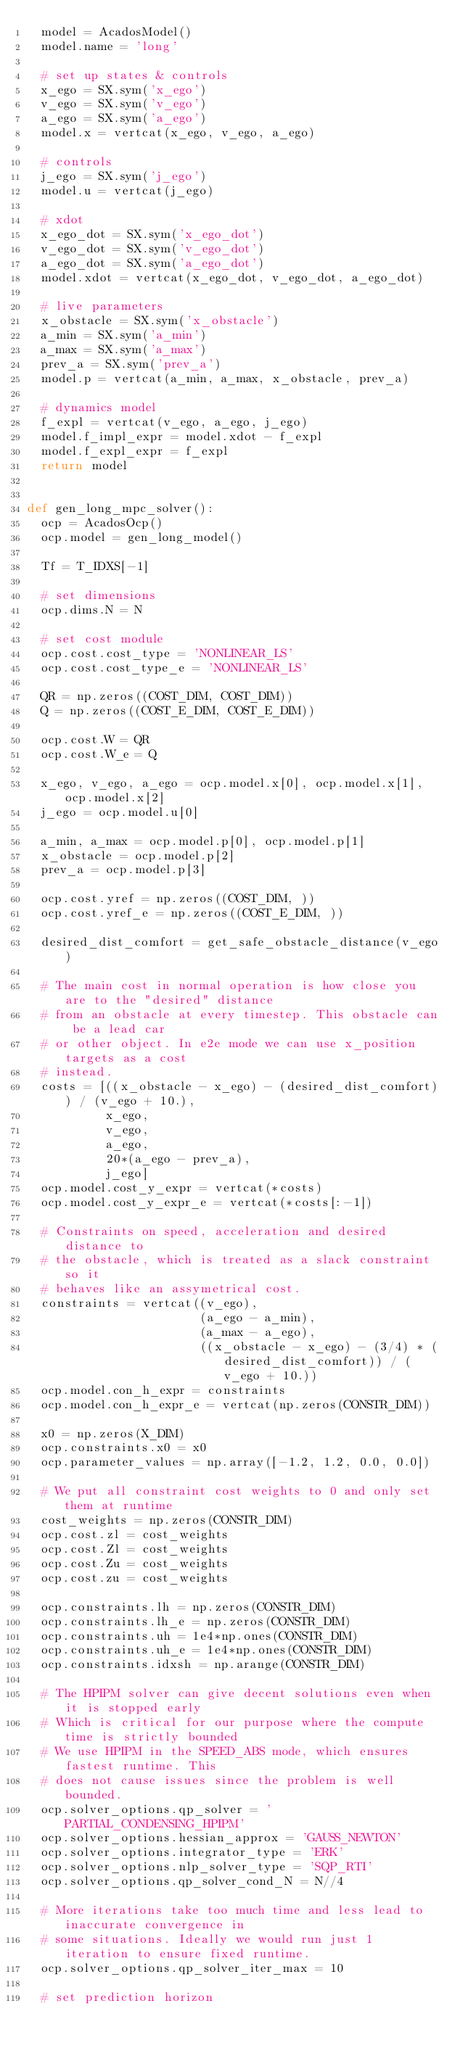<code> <loc_0><loc_0><loc_500><loc_500><_Python_>  model = AcadosModel()
  model.name = 'long'

  # set up states & controls
  x_ego = SX.sym('x_ego')
  v_ego = SX.sym('v_ego')
  a_ego = SX.sym('a_ego')
  model.x = vertcat(x_ego, v_ego, a_ego)

  # controls
  j_ego = SX.sym('j_ego')
  model.u = vertcat(j_ego)

  # xdot
  x_ego_dot = SX.sym('x_ego_dot')
  v_ego_dot = SX.sym('v_ego_dot')
  a_ego_dot = SX.sym('a_ego_dot')
  model.xdot = vertcat(x_ego_dot, v_ego_dot, a_ego_dot)

  # live parameters
  x_obstacle = SX.sym('x_obstacle')
  a_min = SX.sym('a_min')
  a_max = SX.sym('a_max')
  prev_a = SX.sym('prev_a')
  model.p = vertcat(a_min, a_max, x_obstacle, prev_a)

  # dynamics model
  f_expl = vertcat(v_ego, a_ego, j_ego)
  model.f_impl_expr = model.xdot - f_expl
  model.f_expl_expr = f_expl
  return model


def gen_long_mpc_solver():
  ocp = AcadosOcp()
  ocp.model = gen_long_model()

  Tf = T_IDXS[-1]

  # set dimensions
  ocp.dims.N = N

  # set cost module
  ocp.cost.cost_type = 'NONLINEAR_LS'
  ocp.cost.cost_type_e = 'NONLINEAR_LS'

  QR = np.zeros((COST_DIM, COST_DIM))
  Q = np.zeros((COST_E_DIM, COST_E_DIM))

  ocp.cost.W = QR
  ocp.cost.W_e = Q

  x_ego, v_ego, a_ego = ocp.model.x[0], ocp.model.x[1], ocp.model.x[2]
  j_ego = ocp.model.u[0]

  a_min, a_max = ocp.model.p[0], ocp.model.p[1]
  x_obstacle = ocp.model.p[2]
  prev_a = ocp.model.p[3]

  ocp.cost.yref = np.zeros((COST_DIM, ))
  ocp.cost.yref_e = np.zeros((COST_E_DIM, ))

  desired_dist_comfort = get_safe_obstacle_distance(v_ego)

  # The main cost in normal operation is how close you are to the "desired" distance
  # from an obstacle at every timestep. This obstacle can be a lead car
  # or other object. In e2e mode we can use x_position targets as a cost
  # instead.
  costs = [((x_obstacle - x_ego) - (desired_dist_comfort)) / (v_ego + 10.),
           x_ego,
           v_ego,
           a_ego,
           20*(a_ego - prev_a),
           j_ego]
  ocp.model.cost_y_expr = vertcat(*costs)
  ocp.model.cost_y_expr_e = vertcat(*costs[:-1])

  # Constraints on speed, acceleration and desired distance to
  # the obstacle, which is treated as a slack constraint so it
  # behaves like an assymetrical cost.
  constraints = vertcat((v_ego),
                        (a_ego - a_min),
                        (a_max - a_ego),
                        ((x_obstacle - x_ego) - (3/4) * (desired_dist_comfort)) / (v_ego + 10.))
  ocp.model.con_h_expr = constraints
  ocp.model.con_h_expr_e = vertcat(np.zeros(CONSTR_DIM))

  x0 = np.zeros(X_DIM)
  ocp.constraints.x0 = x0
  ocp.parameter_values = np.array([-1.2, 1.2, 0.0, 0.0])

  # We put all constraint cost weights to 0 and only set them at runtime
  cost_weights = np.zeros(CONSTR_DIM)
  ocp.cost.zl = cost_weights
  ocp.cost.Zl = cost_weights
  ocp.cost.Zu = cost_weights
  ocp.cost.zu = cost_weights

  ocp.constraints.lh = np.zeros(CONSTR_DIM)
  ocp.constraints.lh_e = np.zeros(CONSTR_DIM)
  ocp.constraints.uh = 1e4*np.ones(CONSTR_DIM)
  ocp.constraints.uh_e = 1e4*np.ones(CONSTR_DIM)
  ocp.constraints.idxsh = np.arange(CONSTR_DIM)

  # The HPIPM solver can give decent solutions even when it is stopped early
  # Which is critical for our purpose where the compute time is strictly bounded
  # We use HPIPM in the SPEED_ABS mode, which ensures fastest runtime. This
  # does not cause issues since the problem is well bounded.
  ocp.solver_options.qp_solver = 'PARTIAL_CONDENSING_HPIPM'
  ocp.solver_options.hessian_approx = 'GAUSS_NEWTON'
  ocp.solver_options.integrator_type = 'ERK'
  ocp.solver_options.nlp_solver_type = 'SQP_RTI'
  ocp.solver_options.qp_solver_cond_N = N//4

  # More iterations take too much time and less lead to inaccurate convergence in
  # some situations. Ideally we would run just 1 iteration to ensure fixed runtime.
  ocp.solver_options.qp_solver_iter_max = 10

  # set prediction horizon</code> 